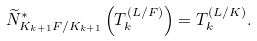Convert formula to latex. <formula><loc_0><loc_0><loc_500><loc_500>\widetilde { N } _ { K _ { k + 1 } F / K _ { k + 1 } } ^ { * } \left ( T _ { k } ^ { ( L / F ) } \right ) = T _ { k } ^ { ( L / K ) } .</formula> 